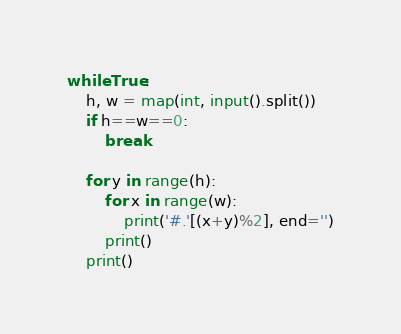Convert code to text. <code><loc_0><loc_0><loc_500><loc_500><_Python_>while True:
    h, w = map(int, input().split())
    if h==w==0:
        break

    for y in range(h):
        for x in range(w):
            print('#.'[(x+y)%2], end='')
        print()
    print()
</code> 